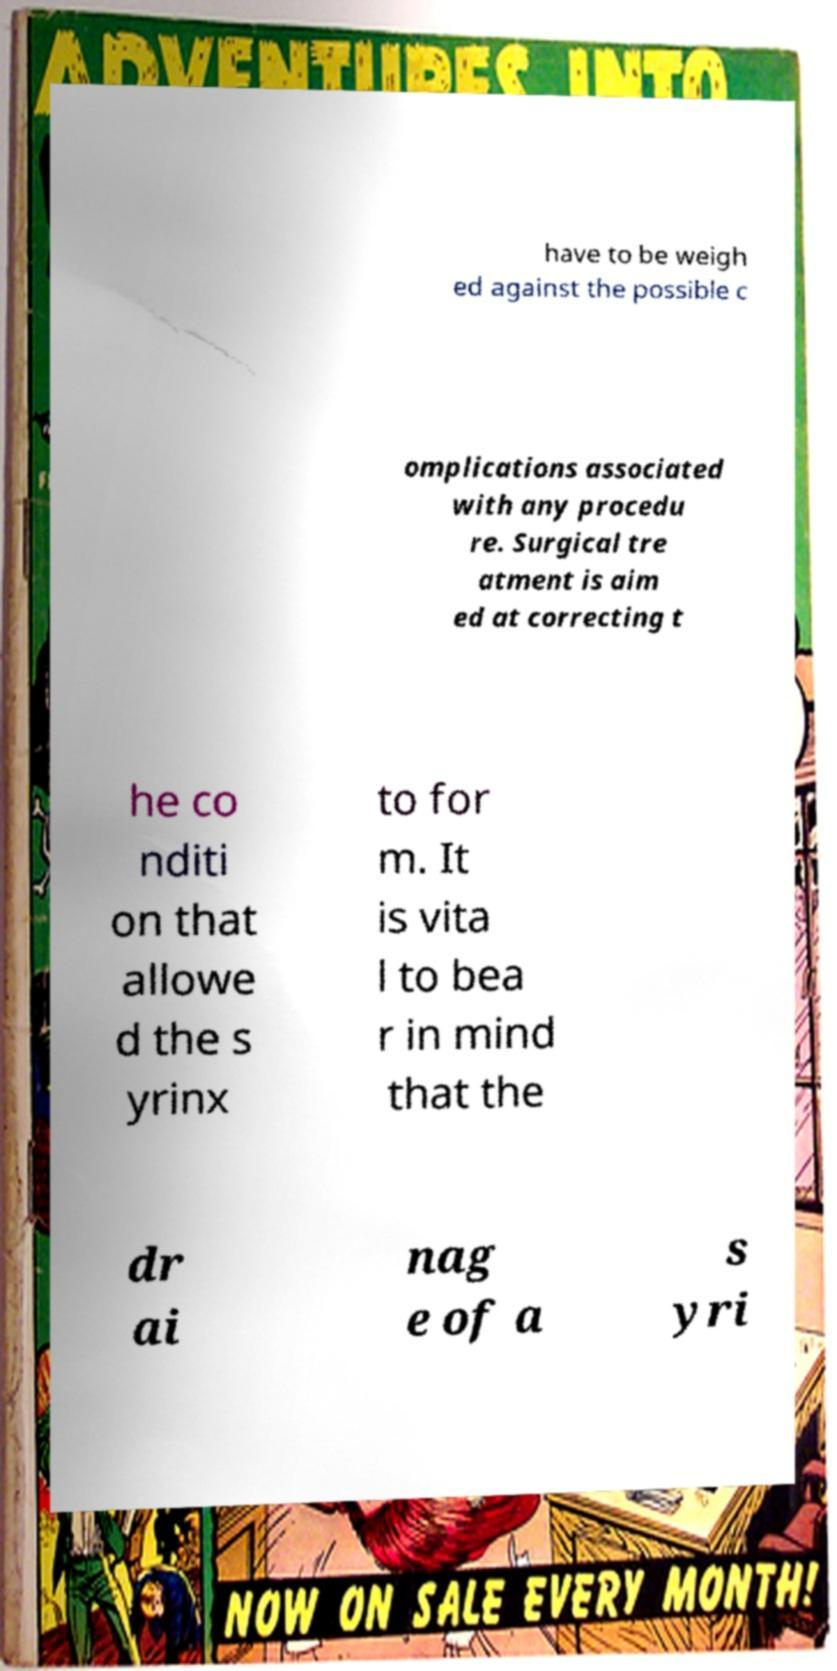Could you extract and type out the text from this image? have to be weigh ed against the possible c omplications associated with any procedu re. Surgical tre atment is aim ed at correcting t he co nditi on that allowe d the s yrinx to for m. It is vita l to bea r in mind that the dr ai nag e of a s yri 